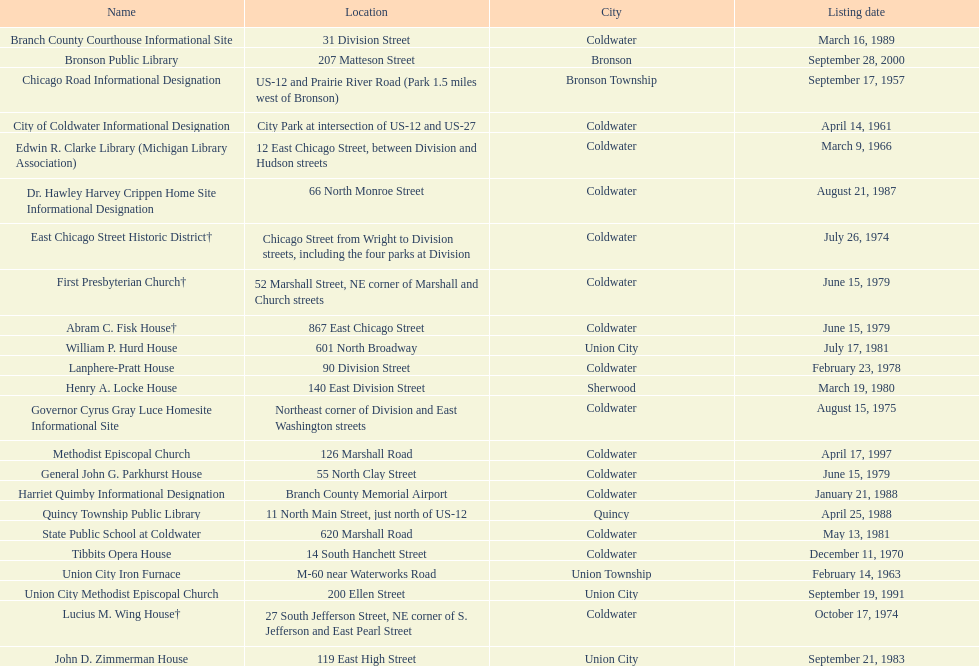How many historical sites were identified before the year 1980? 12. 